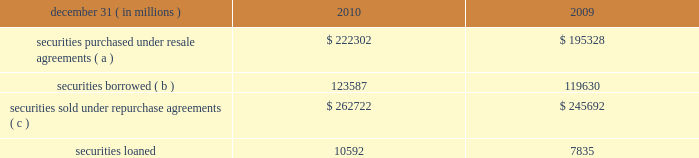Jpmorgan chase & co./2010 annual report 219 note 13 2013 securities financing activities jpmorgan chase enters into resale agreements , repurchase agreements , securities borrowed transactions and securities loaned transactions ( collectively , 201csecurities financing agree- ments 201d ) primarily to finance the firm 2019s inventory positions , ac- quire securities to cover short positions , accommodate customers 2019 financing needs , and settle other securities obligations .
Securities financing agreements are treated as collateralized financings on the firm 2019s consolidated balance sheets .
Resale and repurchase agreements are generally carried at the amounts at which the securities will be subsequently sold or repurchased , plus accrued interest .
Securities borrowed and securities loaned transactions are generally carried at the amount of cash collateral advanced or received .
Where appropriate under applicable ac- counting guidance , resale and repurchase agreements with the same counterparty are reported on a net basis .
Fees received or paid in connection with securities financing agreements are recorded in interest income or interest expense .
The firm has elected the fair value option for certain securities financing agreements .
For a further discussion of the fair value option , see note 4 on pages 187 2013189 of this annual report .
The securities financing agreements for which the fair value option has been elected are reported within securities purchased under resale agreements ; securities loaned or sold under repurchase agreements ; and securities borrowed on the consolidated bal- ance sheets .
Generally , for agreements carried at fair value , current-period interest accruals are recorded within interest income and interest expense , with changes in fair value reported in principal transactions revenue .
However , for financial instru- ments containing embedded derivatives that would be separately accounted for in accordance with accounting guidance for hybrid instruments , all changes in fair value , including any interest elements , are reported in principal transactions revenue .
The table details the firm 2019s securities financing agree- ments , all of which are accounted for as collateralized financings during the periods presented. .
( a ) includes resale agreements of $ 20.3 billion and $ 20.5 billion accounted for at fair value at december 31 , 2010 and 2009 , respectively .
( b ) includes securities borrowed of $ 14.0 billion and $ 7.0 billion accounted for at fair value at december 31 , 2010 and 2009 , respectively .
( c ) includes repurchase agreements of $ 4.1 billion and $ 3.4 billion accounted for at fair value at december 31 , 2010 and 2009 , respectively .
The amounts reported in the table above have been reduced by $ 112.7 billion and $ 121.2 billion at december 31 , 2010 and 2009 , respectively , as a result of agreements in effect that meet the specified conditions for net presentation under applicable accounting guidance .
Jpmorgan chase 2019s policy is to take possession , where possible , of securities purchased under resale agreements and of securi- ties borrowed .
The firm monitors the market value of the un- derlying securities that it has received from its counterparties and either requests additional collateral or returns a portion of the collateral when appropriate in light of the market value of the underlying securities .
Margin levels are established initially based upon the counterparty and type of collateral and moni- tored on an ongoing basis to protect against declines in collat- eral value in the event of default .
Jpmorgan chase typically enters into master netting agreements and other collateral arrangements with its resale agreement and securities bor- rowed counterparties , which provide for the right to liquidate the purchased or borrowed securities in the event of a customer default .
As a result of the firm 2019s credit risk mitigation practices described above on resale and securities borrowed agreements , the firm did not hold any reserves for credit impairment on these agreements as of december 31 , 2010 and 2009 .
For a further discussion of assets pledged and collateral received in securities financing agreements see note 31 on pages 280 2013 281 of this annual report. .
In 2010 what was the percent of the securities borrowed accounted for at fair value? 
Computations: (14.0 / 123587)
Answer: 0.00011. 